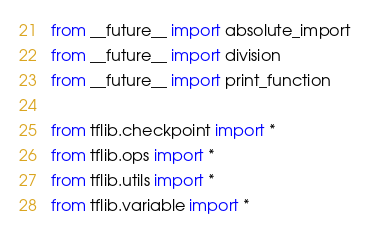<code> <loc_0><loc_0><loc_500><loc_500><_Python_>from __future__ import absolute_import
from __future__ import division
from __future__ import print_function

from tflib.checkpoint import *
from tflib.ops import *
from tflib.utils import *
from tflib.variable import *
</code> 